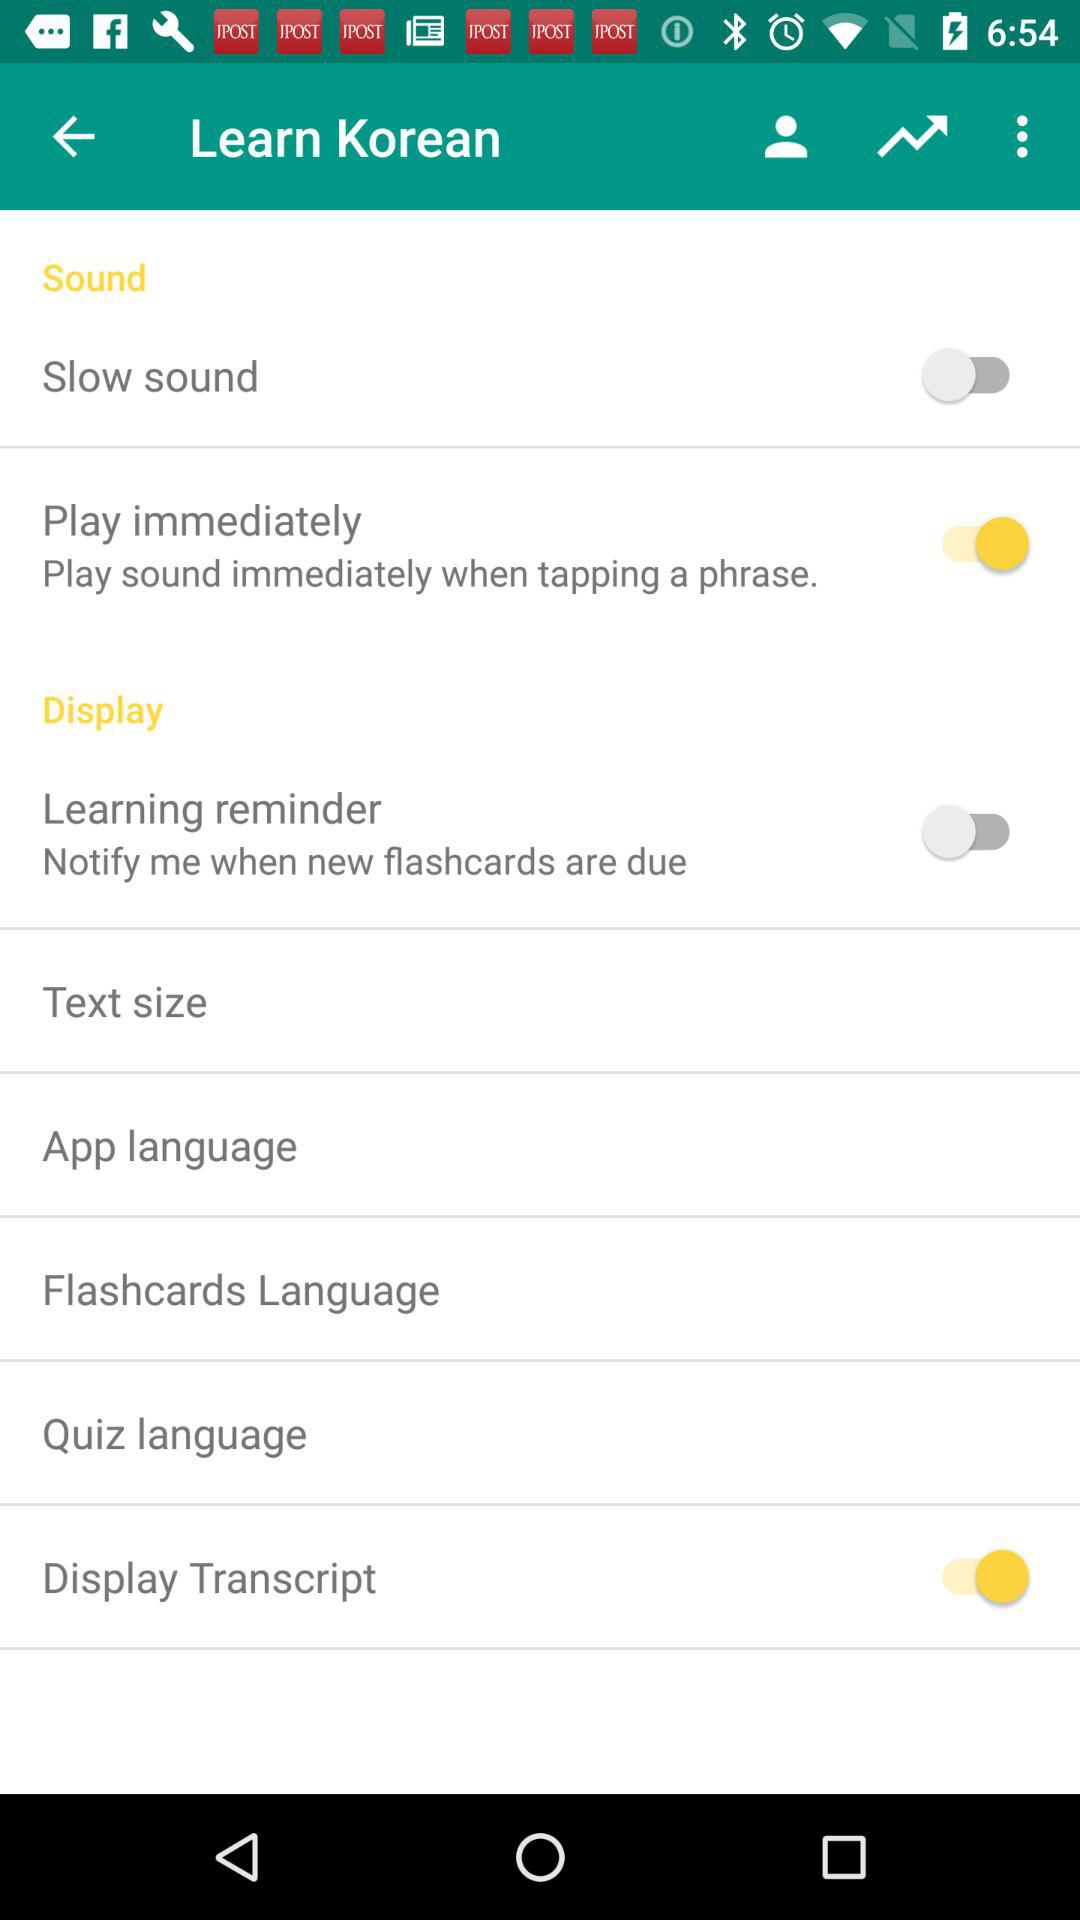What is the status of "Learning reminder"? The status of "Learning reminder" is "off". 